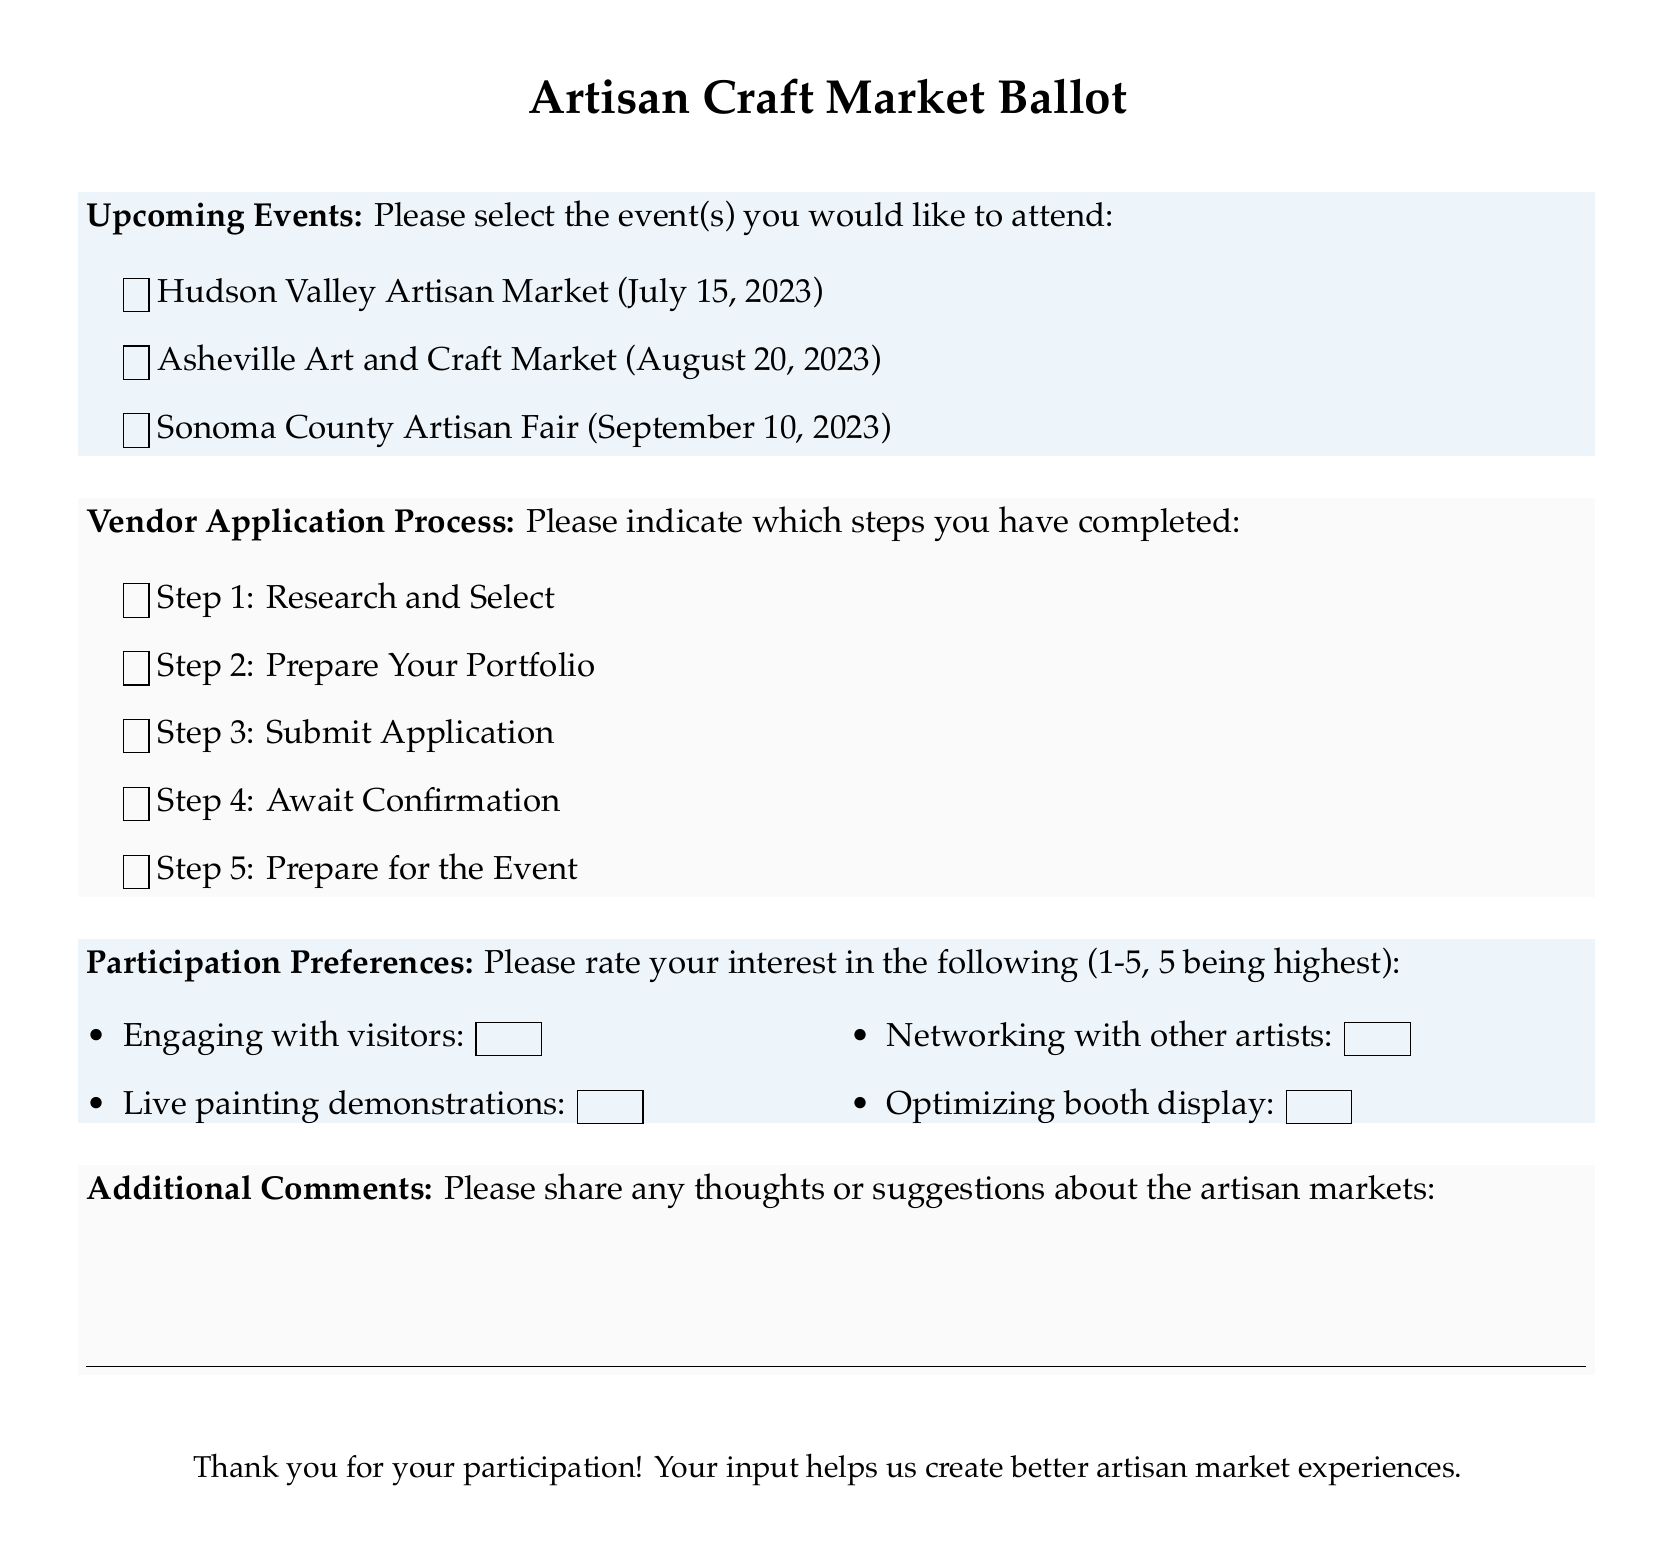What is the date of the Hudson Valley Artisan Market? The date is provided in the document under Upcoming Events, listing the Hudson Valley Artisan Market date as July 15, 2023.
Answer: July 15, 2023 How many steps are in the Vendor Application Process? The Vendor Application Process consists of five steps as outlined in the document.
Answer: 5 What type of market is scheduled for September 10, 2023? The document specifies the event as the Sonoma County Artisan Fair.
Answer: Sonoma County Artisan Fair What does the participation preference "Live painting demonstrations" indicate? This refers to the participants' interest level in engaging with visitors through live art creation, rated 1-5.
Answer: 1-5 scale Which step comes after "Prepare Your Portfolio" in the Vendor Application Process? According to the document, Step 3 follows Step 2 in the application process.
Answer: Submit Application What color is used for the "Upcoming Events" section? The document uses a specific RGB color for the "Upcoming Events" section, labeled as ballotblue.
Answer: Ballotblue What is the purpose of the “Additional Comments” section? This section allows participants to provide thoughts or suggestions regarding the artisan markets.
Answer: Feedback What type of item is mentioned under "Participation Preferences"? The item refers to various engagement activities, specifically "Engaging with visitors."
Answer: Activities 